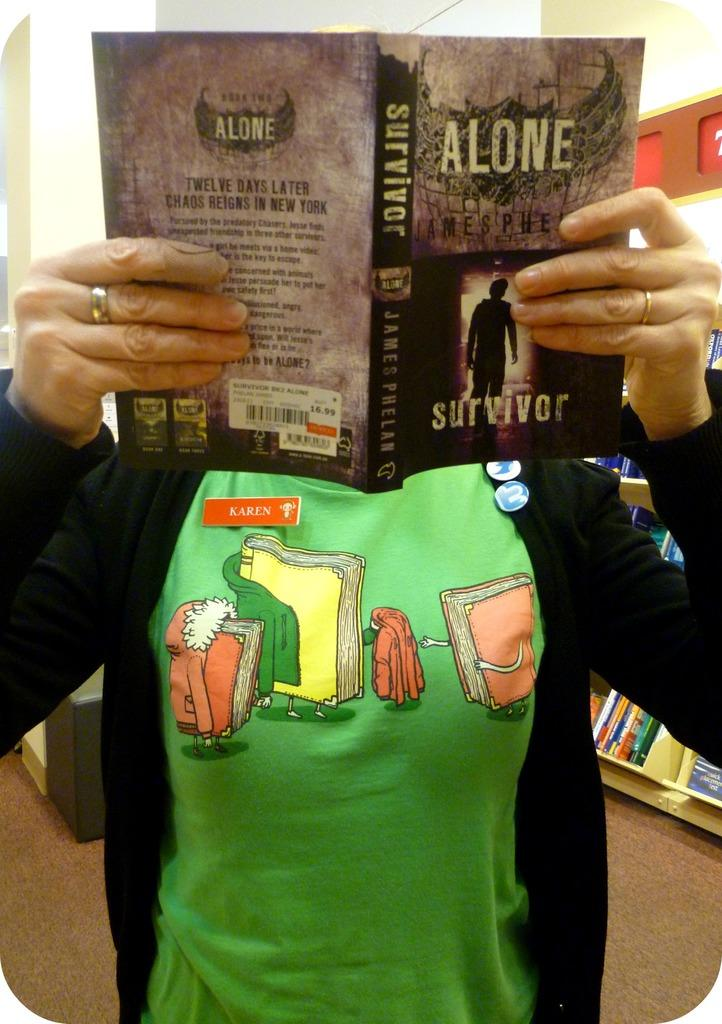<image>
Write a terse but informative summary of the picture. Someone named Karen is reading a book called Alone. 